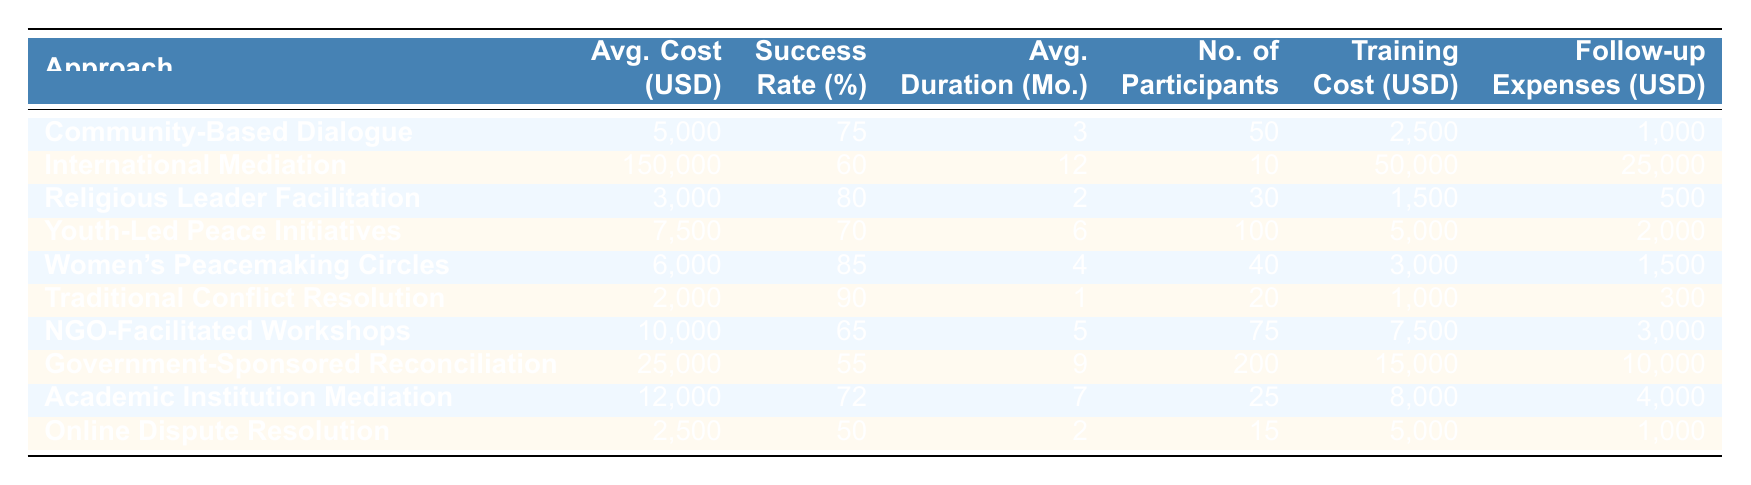What is the average cost per case for Community-Based Dialogue? The table shows that the average cost per case for Community-Based Dialogue is listed as 5,000 USD.
Answer: 5,000 USD Which approach has the highest success rate? By comparing the success rates, Women's Peacemaking Circles have the highest success rate at 85%.
Answer: Women's Peacemaking Circles What is the average duration of International Mediation? The average duration for International Mediation is indicated in the table as 12 months.
Answer: 12 months Calculate the total training cost for all approaches combined. The training costs are: 2,500 + 50,000 + 1,500 + 5,000 + 3,000 + 1,000 + 7,500 + 15,000 + 8,000 + 5,000 = 98,500 USD.
Answer: 98,500 USD Is the follow-up expense for Traditional Conflict Resolution greater than that for Online Dispute Resolution? Traditional Conflict Resolution has follow-up expenses of 300 USD, while Online Dispute Resolution has 1,000 USD. Since 300 < 1,000, the statement is false.
Answer: No What is the average number of participants across all mediation approaches? To find the average number of participants, sum all participants: 50 + 10 + 30 + 100 + 40 + 20 + 75 + 200 + 25 + 15 = 570. Then, divide by 10 (number of approaches): 570/10 = 57.
Answer: 57 Which approach offers the lowest average cost per case? Comparing all average costs, Traditional Conflict Resolution has the lowest cost at 2,000 USD.
Answer: Traditional Conflict Resolution What is the difference in success rate between Religious Leader Facilitation and Government-Sponsored Reconciliation? Religious Leader Facilitation has a success rate of 80%, while Government-Sponsored Reconciliation has 55%. The difference is 80 - 55 = 25%.
Answer: 25% How many approaches have an average cost that is below 10,000 USD? The approaches with costs below 10,000 USD are: Community-Based Dialogue, Religious Leader Facilitation, Youth-Led Peace Initiatives, Women's Peacemaking Circles, Traditional Conflict Resolution, and Online Dispute Resolution, totaling 6 approaches.
Answer: 6 Which mediation approach has the highest number of participants? Government-Sponsored Reconciliation has the highest number of participants at 200.
Answer: Government-Sponsored Reconciliation 